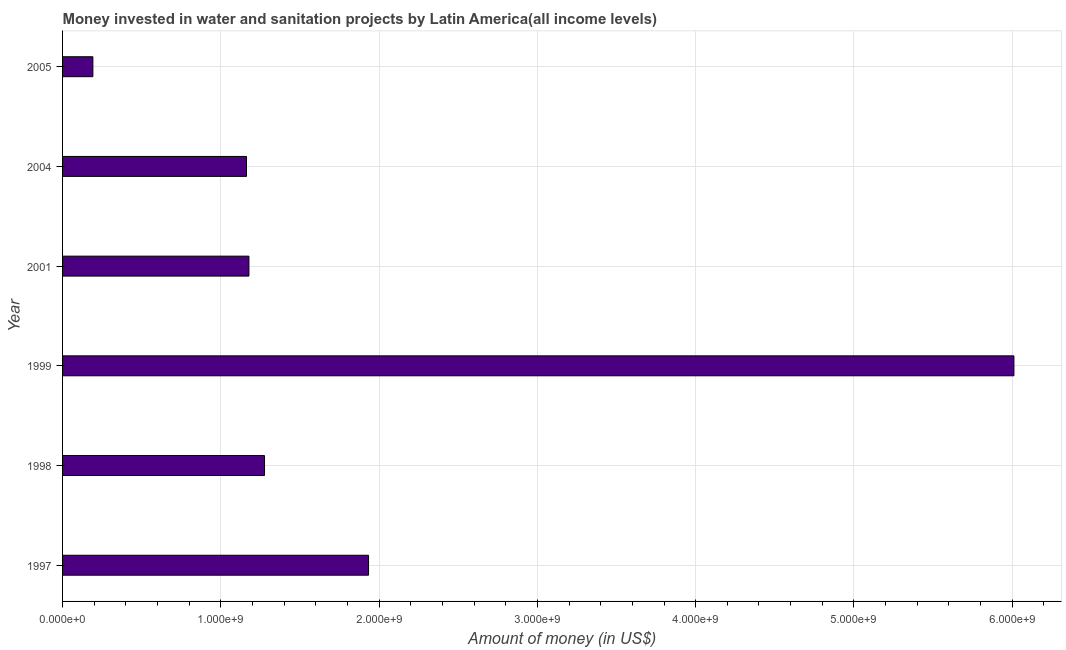Does the graph contain grids?
Offer a very short reply. Yes. What is the title of the graph?
Give a very brief answer. Money invested in water and sanitation projects by Latin America(all income levels). What is the label or title of the X-axis?
Provide a succinct answer. Amount of money (in US$). What is the investment in 1999?
Offer a very short reply. 6.01e+09. Across all years, what is the maximum investment?
Keep it short and to the point. 6.01e+09. Across all years, what is the minimum investment?
Ensure brevity in your answer.  1.91e+08. In which year was the investment minimum?
Ensure brevity in your answer.  2005. What is the sum of the investment?
Provide a short and direct response. 1.18e+1. What is the difference between the investment in 1999 and 2001?
Keep it short and to the point. 4.83e+09. What is the average investment per year?
Offer a terse response. 1.96e+09. What is the median investment?
Make the answer very short. 1.23e+09. In how many years, is the investment greater than 3400000000 US$?
Give a very brief answer. 1. What is the ratio of the investment in 1998 to that in 2001?
Offer a very short reply. 1.08. Is the investment in 1997 less than that in 2001?
Keep it short and to the point. No. Is the difference between the investment in 2001 and 2004 greater than the difference between any two years?
Provide a short and direct response. No. What is the difference between the highest and the second highest investment?
Give a very brief answer. 4.08e+09. What is the difference between the highest and the lowest investment?
Your answer should be compact. 5.82e+09. In how many years, is the investment greater than the average investment taken over all years?
Your answer should be very brief. 1. Are all the bars in the graph horizontal?
Give a very brief answer. Yes. What is the difference between two consecutive major ticks on the X-axis?
Offer a very short reply. 1.00e+09. Are the values on the major ticks of X-axis written in scientific E-notation?
Keep it short and to the point. Yes. What is the Amount of money (in US$) in 1997?
Ensure brevity in your answer.  1.93e+09. What is the Amount of money (in US$) of 1998?
Offer a very short reply. 1.28e+09. What is the Amount of money (in US$) in 1999?
Your response must be concise. 6.01e+09. What is the Amount of money (in US$) of 2001?
Offer a very short reply. 1.18e+09. What is the Amount of money (in US$) of 2004?
Your answer should be compact. 1.16e+09. What is the Amount of money (in US$) in 2005?
Give a very brief answer. 1.91e+08. What is the difference between the Amount of money (in US$) in 1997 and 1998?
Provide a succinct answer. 6.57e+08. What is the difference between the Amount of money (in US$) in 1997 and 1999?
Provide a short and direct response. -4.08e+09. What is the difference between the Amount of money (in US$) in 1997 and 2001?
Your response must be concise. 7.56e+08. What is the difference between the Amount of money (in US$) in 1997 and 2004?
Keep it short and to the point. 7.71e+08. What is the difference between the Amount of money (in US$) in 1997 and 2005?
Ensure brevity in your answer.  1.74e+09. What is the difference between the Amount of money (in US$) in 1998 and 1999?
Your response must be concise. -4.73e+09. What is the difference between the Amount of money (in US$) in 1998 and 2001?
Offer a terse response. 9.85e+07. What is the difference between the Amount of money (in US$) in 1998 and 2004?
Make the answer very short. 1.14e+08. What is the difference between the Amount of money (in US$) in 1998 and 2005?
Ensure brevity in your answer.  1.08e+09. What is the difference between the Amount of money (in US$) in 1999 and 2001?
Keep it short and to the point. 4.83e+09. What is the difference between the Amount of money (in US$) in 1999 and 2004?
Offer a terse response. 4.85e+09. What is the difference between the Amount of money (in US$) in 1999 and 2005?
Make the answer very short. 5.82e+09. What is the difference between the Amount of money (in US$) in 2001 and 2004?
Your answer should be very brief. 1.54e+07. What is the difference between the Amount of money (in US$) in 2001 and 2005?
Keep it short and to the point. 9.86e+08. What is the difference between the Amount of money (in US$) in 2004 and 2005?
Provide a succinct answer. 9.71e+08. What is the ratio of the Amount of money (in US$) in 1997 to that in 1998?
Your answer should be very brief. 1.51. What is the ratio of the Amount of money (in US$) in 1997 to that in 1999?
Keep it short and to the point. 0.32. What is the ratio of the Amount of money (in US$) in 1997 to that in 2001?
Ensure brevity in your answer.  1.64. What is the ratio of the Amount of money (in US$) in 1997 to that in 2004?
Your answer should be very brief. 1.66. What is the ratio of the Amount of money (in US$) in 1997 to that in 2005?
Offer a terse response. 10.1. What is the ratio of the Amount of money (in US$) in 1998 to that in 1999?
Offer a terse response. 0.21. What is the ratio of the Amount of money (in US$) in 1998 to that in 2001?
Your answer should be compact. 1.08. What is the ratio of the Amount of money (in US$) in 1998 to that in 2004?
Provide a short and direct response. 1.1. What is the ratio of the Amount of money (in US$) in 1998 to that in 2005?
Offer a terse response. 6.67. What is the ratio of the Amount of money (in US$) in 1999 to that in 2001?
Keep it short and to the point. 5.11. What is the ratio of the Amount of money (in US$) in 1999 to that in 2004?
Your answer should be compact. 5.17. What is the ratio of the Amount of money (in US$) in 1999 to that in 2005?
Give a very brief answer. 31.4. What is the ratio of the Amount of money (in US$) in 2001 to that in 2005?
Keep it short and to the point. 6.15. What is the ratio of the Amount of money (in US$) in 2004 to that in 2005?
Ensure brevity in your answer.  6.07. 